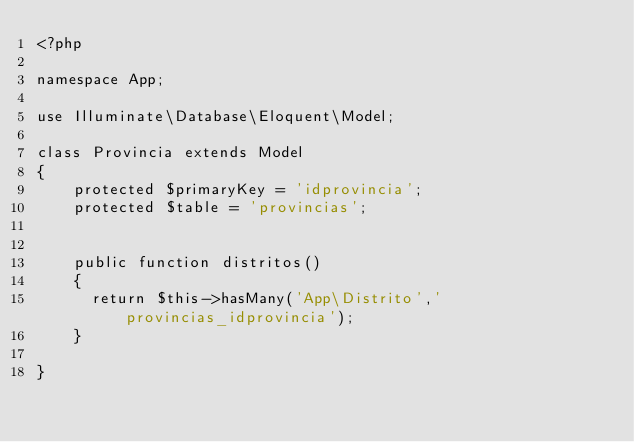<code> <loc_0><loc_0><loc_500><loc_500><_PHP_><?php

namespace App;

use Illuminate\Database\Eloquent\Model;

class Provincia extends Model
{
    protected $primaryKey = 'idprovincia';
    protected $table = 'provincias';


    public function distritos()
    {
      return $this->hasMany('App\Distrito','provincias_idprovincia');
    }

}
</code> 